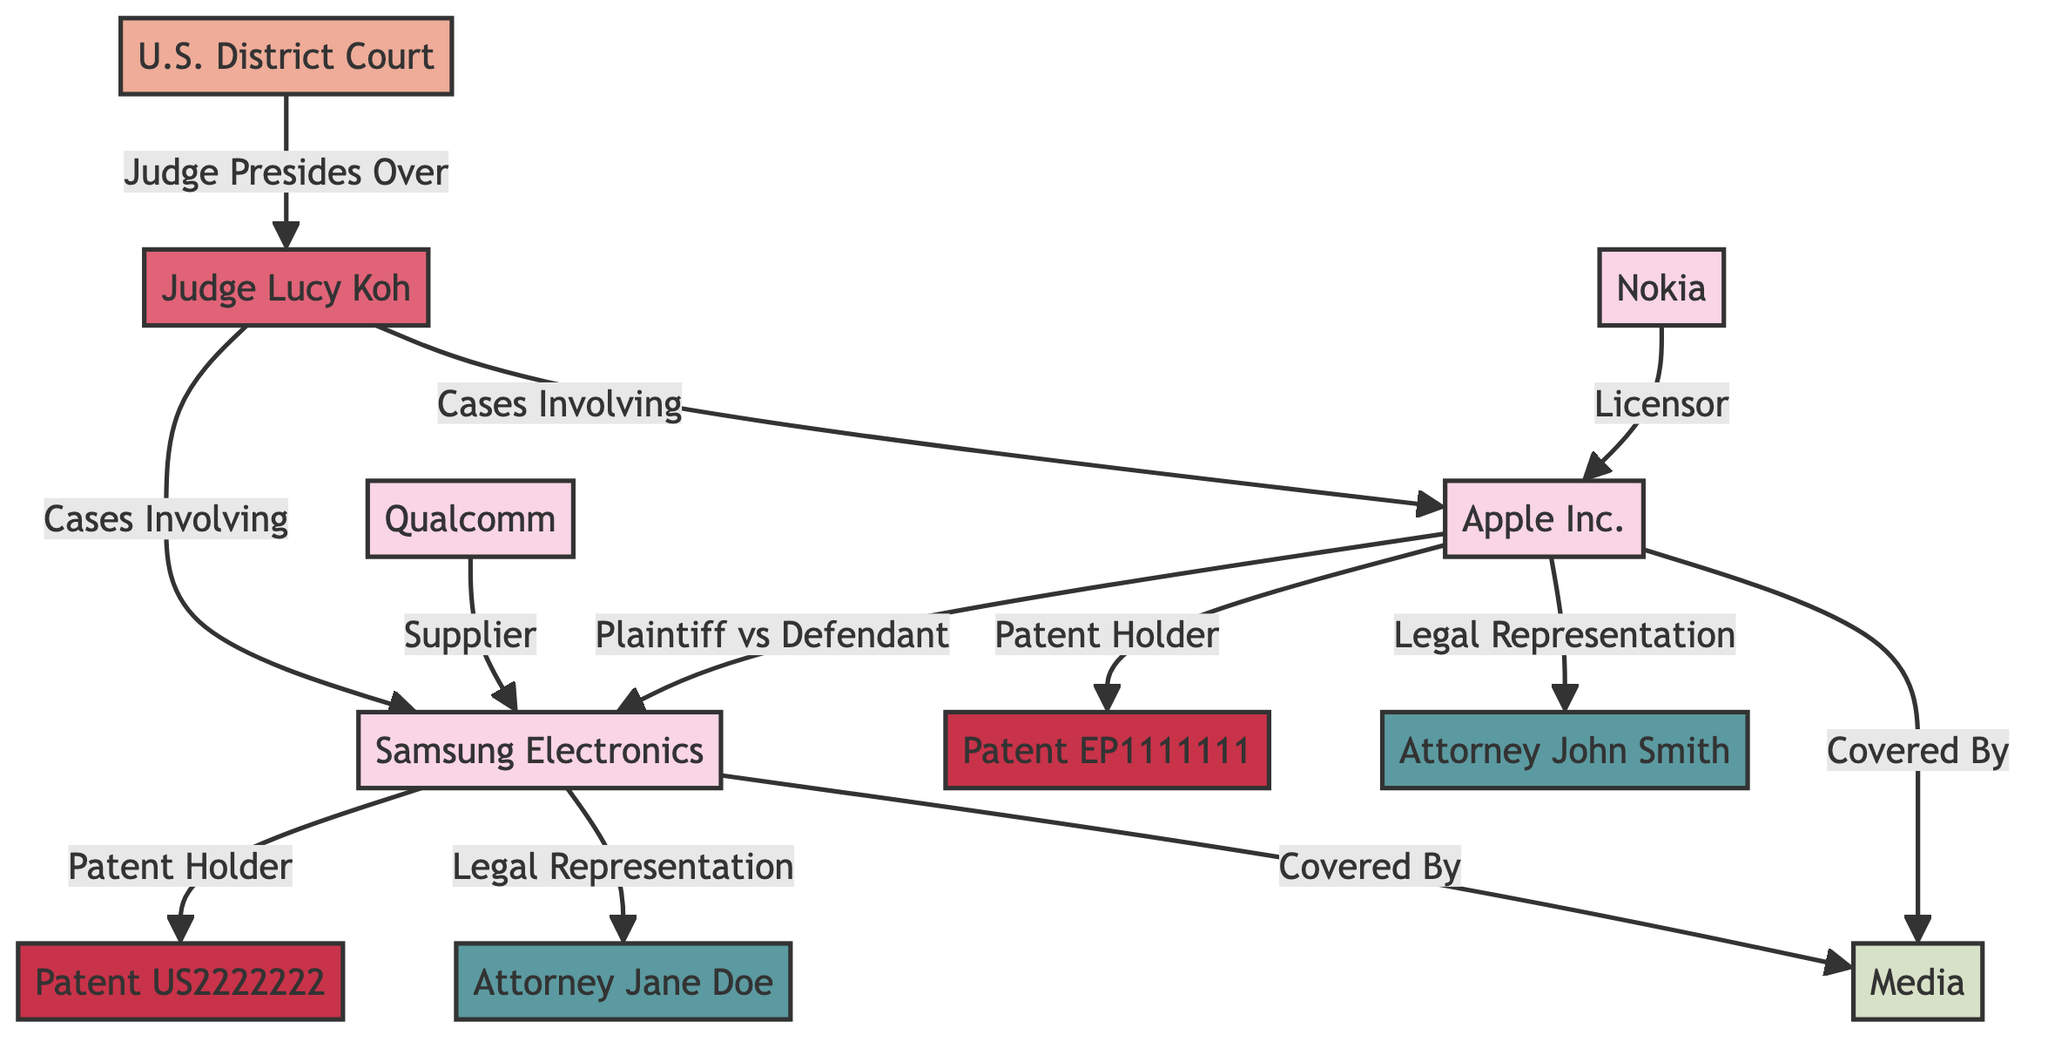What is the total number of nodes in the diagram? There are ten unique nodes listed in the data, which represent the key stakeholders involved in the IP lawsuit.
Answer: 10 Who is the Plaintiff in the lawsuit represented in the diagram? The relationship between Apple Inc. and Samsung Electronics is indicated as "Plaintiff vs Defendant," making Apple Inc. the Plaintiff.
Answer: Apple Inc What is the relationship between Qualcomm and Samsung Electronics? The links indicate that Qualcomm is a supplier for Samsung Electronics.
Answer: Supplier Who presides over the U.S. District Court for this lawsuit? The connection from the U.S. District Court to Judge Lucy Koh shows that she is the judge presiding over this case.
Answer: Judge Lucy Koh How many patents are represented in the diagram? There are two patents included in the relationships, namely Patent EP1111111 and Patent US2222222.
Answer: 2 Which corporation is licensed by Nokia? The relationship link shows that Nokia is a licensor to Apple Inc., meaning Apple Inc. is the corporation that receives a license from Nokia.
Answer: Apple Inc What role does Media have regarding Apple Inc. and Samsung Electronics? Both Apple Inc. and Samsung Electronics have a relationship with Media identified as "Covered By," indicating that both companies are covered by Media.
Answer: Covered By What attorney is representing Apple Inc.? The relationship specifies that Attorney John Smith is listed as the legal representation for Apple Inc.
Answer: Attorney John Smith Which patent does Samsung Electronics hold? The data specifies that Samsung Electronics is linked to Patent US2222222 as a patent holder.
Answer: Patent US2222222 How many unique relationships are displayed in the diagram? By counting each link in the relationships section, there are a total of twelve unique relationships among the stakeholders.
Answer: 12 